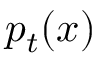<formula> <loc_0><loc_0><loc_500><loc_500>p _ { t } ( x )</formula> 